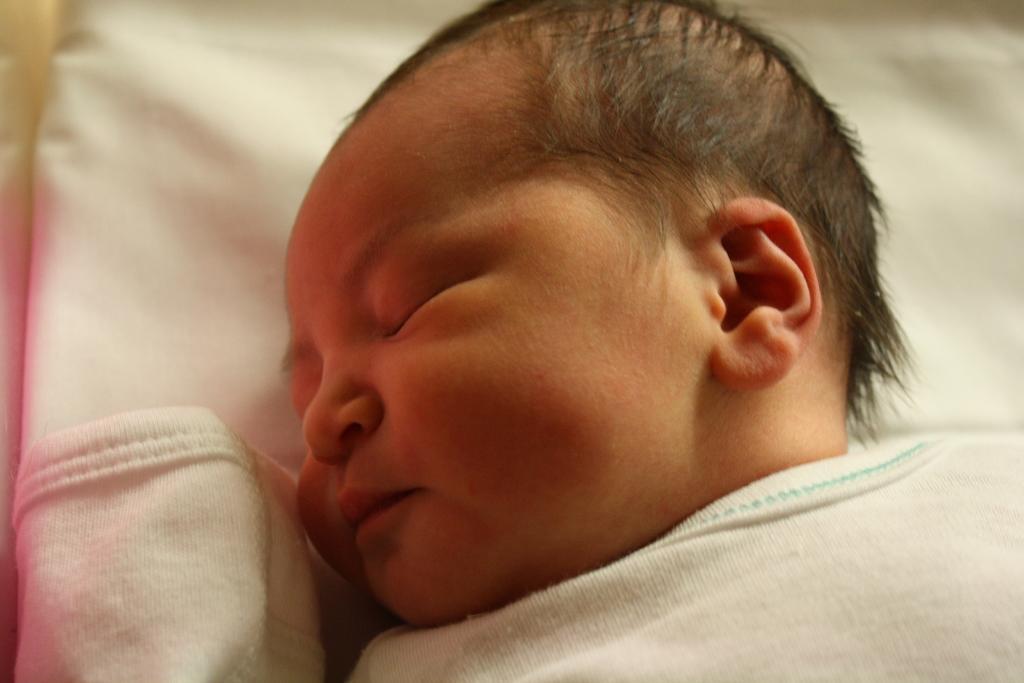In one or two sentences, can you explain what this image depicts? There is a baby laying on white color surface. 